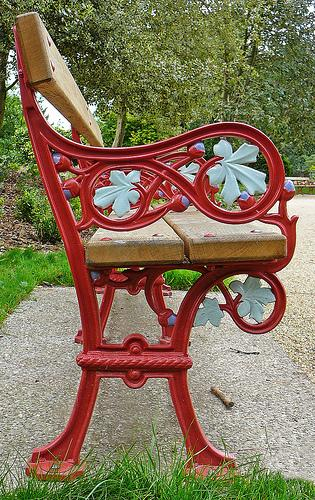What is one notable feature of the seat of the bench in the image? The seat is made of wood, with red bolts painted into the bench seat. Mention any visible natural element present in the image. There are green trees, a small green bush, and a patch of grass surrounding the red bench in the park. List three distinct objects that can be seen in the image. A red metal bench, a white leaf design, and green trees in the park. How would you describe the sentiment of the image? The sentiment of the image is peaceful and serene, with a beautifully designed bench set among the greenery of a park. Can you describe how the bench in the park is decorated? The bench has ornate red metal legs and arms, a wooden seat and back, and white leaf designs and a red flower with a white tip on it. Explain the type of surface the bench is placed on. The bench is placed on a patch of grass with some twigs on the ground in the park. How many benches can be seen in this image? There are two benches in the image, one is in focus, and another one is across the way. Describe one visual aspect that makes the bench unique. The bench has ornate red metal work, including floral armrests and an intricate design on the legs. What is the primary focus of the image? A red metal bench with white designs and wooden back and seat in a park. Identify and describe the material used in the construction of the back of the bench. The back of the bench is made from one wooden board, with red metal parts connecting it to the seat. Does the red bench have armrests made of metal or wood? The armrests are made of ornate red metal. Identify the sentiment evoked by the picture of the park bench. Calm, peaceful, and inviting. What color are the screws in the bench? The screws in the bench are painted red. What is the color of the bench in the image? The bench is red. How is the quality of the image? The quality of the image is clear and precise with well-defined objects. Identify any anomalies in the image of the park bench. A red flower with a white tip on the bench can be considered an anomaly. Notice the squirrel playing near the twigs on the ground and tell me what it is doing? No, it's not mentioned in the image. List the objects and their respective image in the image. - Red metal bench (X:28 Y:107 Width:267 Height:267) What materials are used to make the park bench? The park bench is made of metal and wood. Is there another bench in the image? Yes, there is another bench across the way. Describe the main object in the image. A red metal bench in a park with a wooden back and seat and ornate metalwork on the legs and armrests. What kind of designs can be found on the red bench? White leaf design and white design. Describe the trees in the background. Green trees are seen in the park. Is the seat of the bench made of wood or metal? The seat of the bench is made of wood. Does the red bench have any unique design elements? Yes, it has an ornate floral armrest and ornate red metalwork on the legs. Find the position of the red flower with a white tip in the image. X:166, Y:193, Width:23, Height:23. 